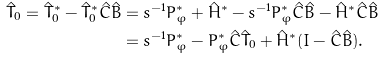<formula> <loc_0><loc_0><loc_500><loc_500>\hat { T } _ { 0 } = \hat { T } _ { 0 } ^ { * } - \hat { T } _ { 0 } ^ { * } \hat { C } \hat { B } & = s ^ { - 1 } P _ { \varphi } ^ { * } + \hat { H } ^ { * } - s ^ { - 1 } P _ { \varphi } ^ { * } \hat { C } \hat { B } - \hat { H } ^ { * } \hat { C } \hat { B } \\ & = s ^ { - 1 } P _ { \varphi } ^ { * } - P _ { \varphi } ^ { * } \hat { C } \hat { T } _ { 0 } + \hat { H } ^ { * } ( I - \hat { C } \hat { B } ) .</formula> 